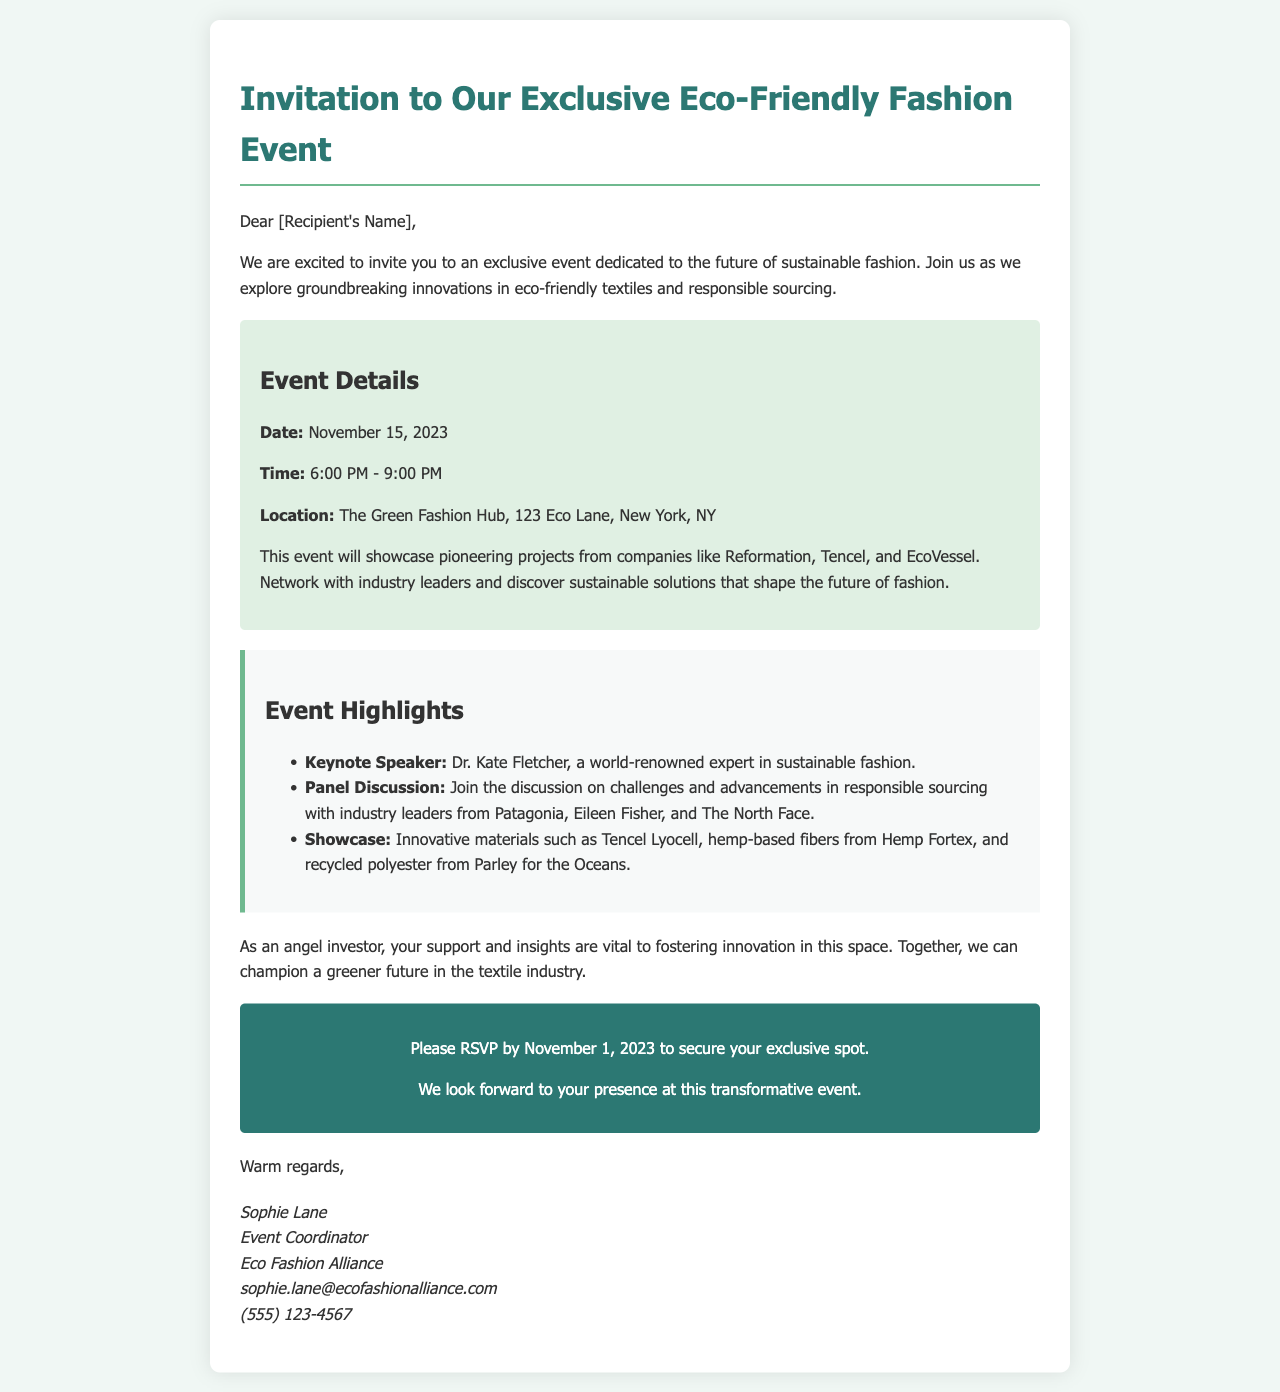What is the date of the event? The date of the event is explicitly stated in the document, which is November 15, 2023.
Answer: November 15, 2023 What is the location of the event? The document specifies the event location as The Green Fashion Hub, 123 Eco Lane, New York, NY.
Answer: The Green Fashion Hub, 123 Eco Lane, New York, NY Who is the keynote speaker? The keynote speaker is identified in the highlights section of the document as Dr. Kate Fletcher.
Answer: Dr. Kate Fletcher Which companies will showcase projects at the event? The document lists Reformation, Tencel, and EcoVessel as companies showcasing their projects at the event.
Answer: Reformation, Tencel, and EcoVessel What is the RSVP deadline? The deadline for RSVP is mentioned in the call to action section, which is November 1, 2023.
Answer: November 1, 2023 What time does the event start? The event start time is provided in the event details section, which is 6:00 PM.
Answer: 6:00 PM What is the main focus of the event? The main focus of the event is described as exploring groundbreaking innovations in eco-friendly textiles and responsible sourcing.
Answer: Eco-friendly textiles and responsible sourcing What type of discussions will take place during the event? The document states that there will be a panel discussion on challenges and advancements in responsible sourcing.
Answer: Challenges and advancements in responsible sourcing 